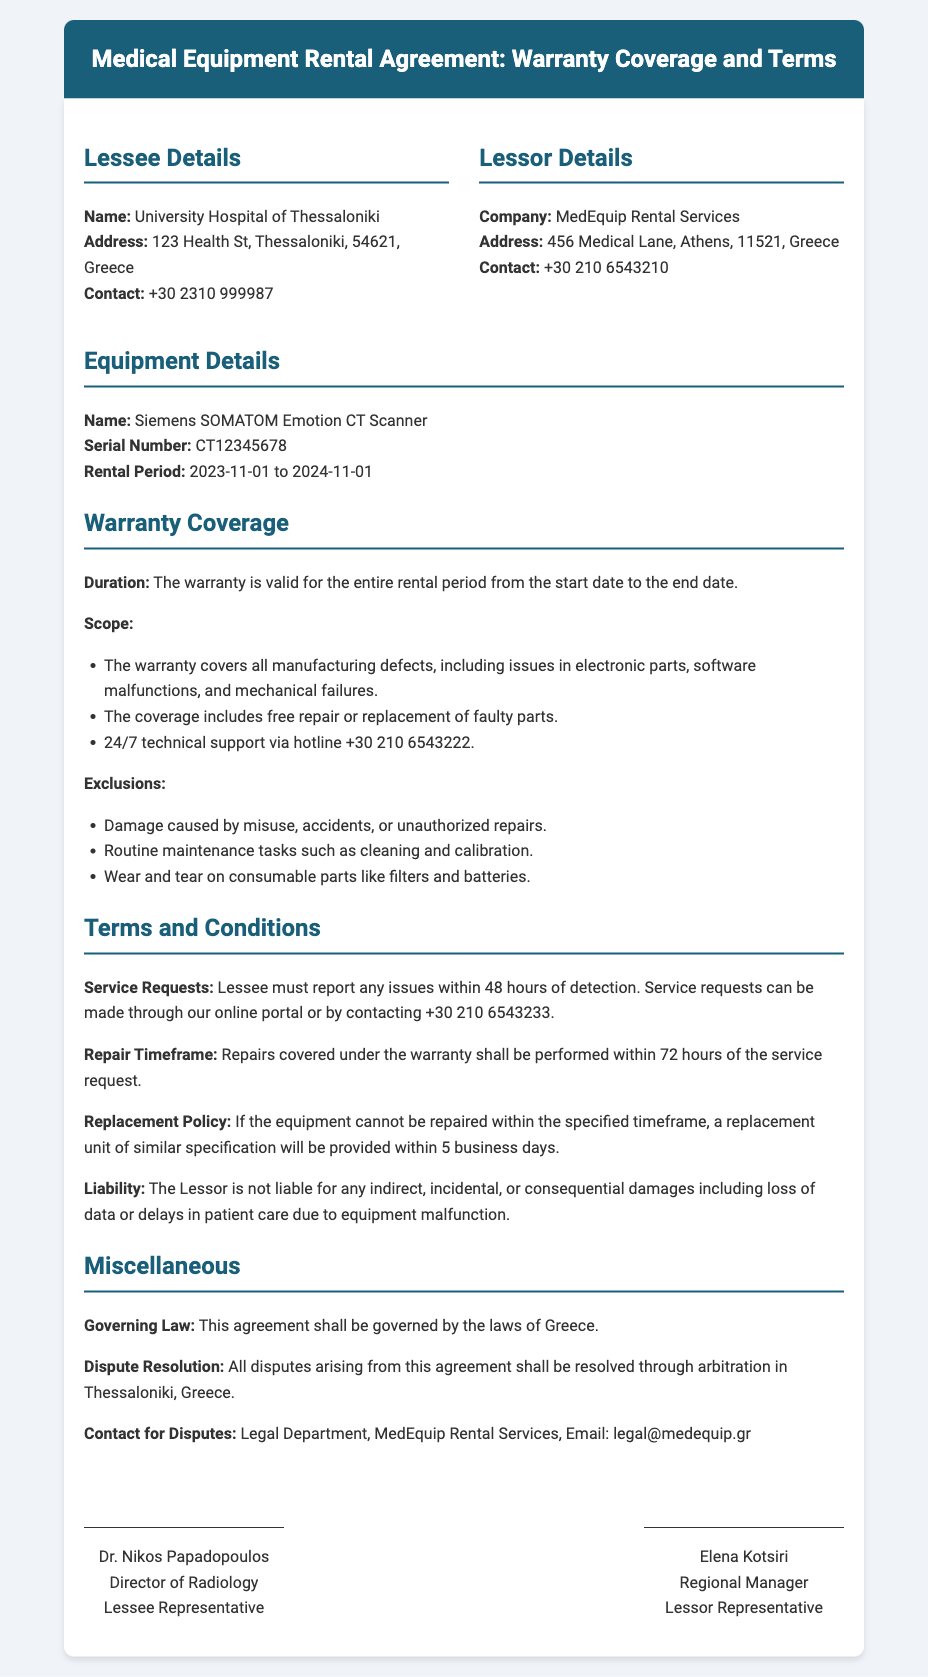what is the name of the lessee? The lessee is identified as the University Hospital of Thessaloniki.
Answer: University Hospital of Thessaloniki what is the equipment covered under the warranty? The document specifies that the equipment is a Siemens SOMATOM Emotion CT Scanner.
Answer: Siemens SOMATOM Emotion CT Scanner what is the warranty duration? The warranty is valid for the entire rental period from the start date to the end date.
Answer: entire rental period how long does the lessee have to report issues? The lessee must report any issues within 48 hours of detection.
Answer: 48 hours what is the contact number for technical support? The document provides a hotline for technical support as +30 210 6543222.
Answer: +30 210 6543222 what are the exclusions under the warranty? Exclusions include damage caused by misuse, routine maintenance tasks, and wear and tear on consumable parts.
Answer: misuse, maintenance, wear and tear how long will repairs take under the warranty? Repairs covered under the warranty are to be performed within 72 hours of the service request.
Answer: 72 hours what happens if the equipment cannot be repaired in time? A replacement unit of similar specification will be provided within 5 business days if repair is not timely.
Answer: 5 business days what is the governing law for this agreement? The governing law for this agreement is specified as the laws of Greece.
Answer: laws of Greece 